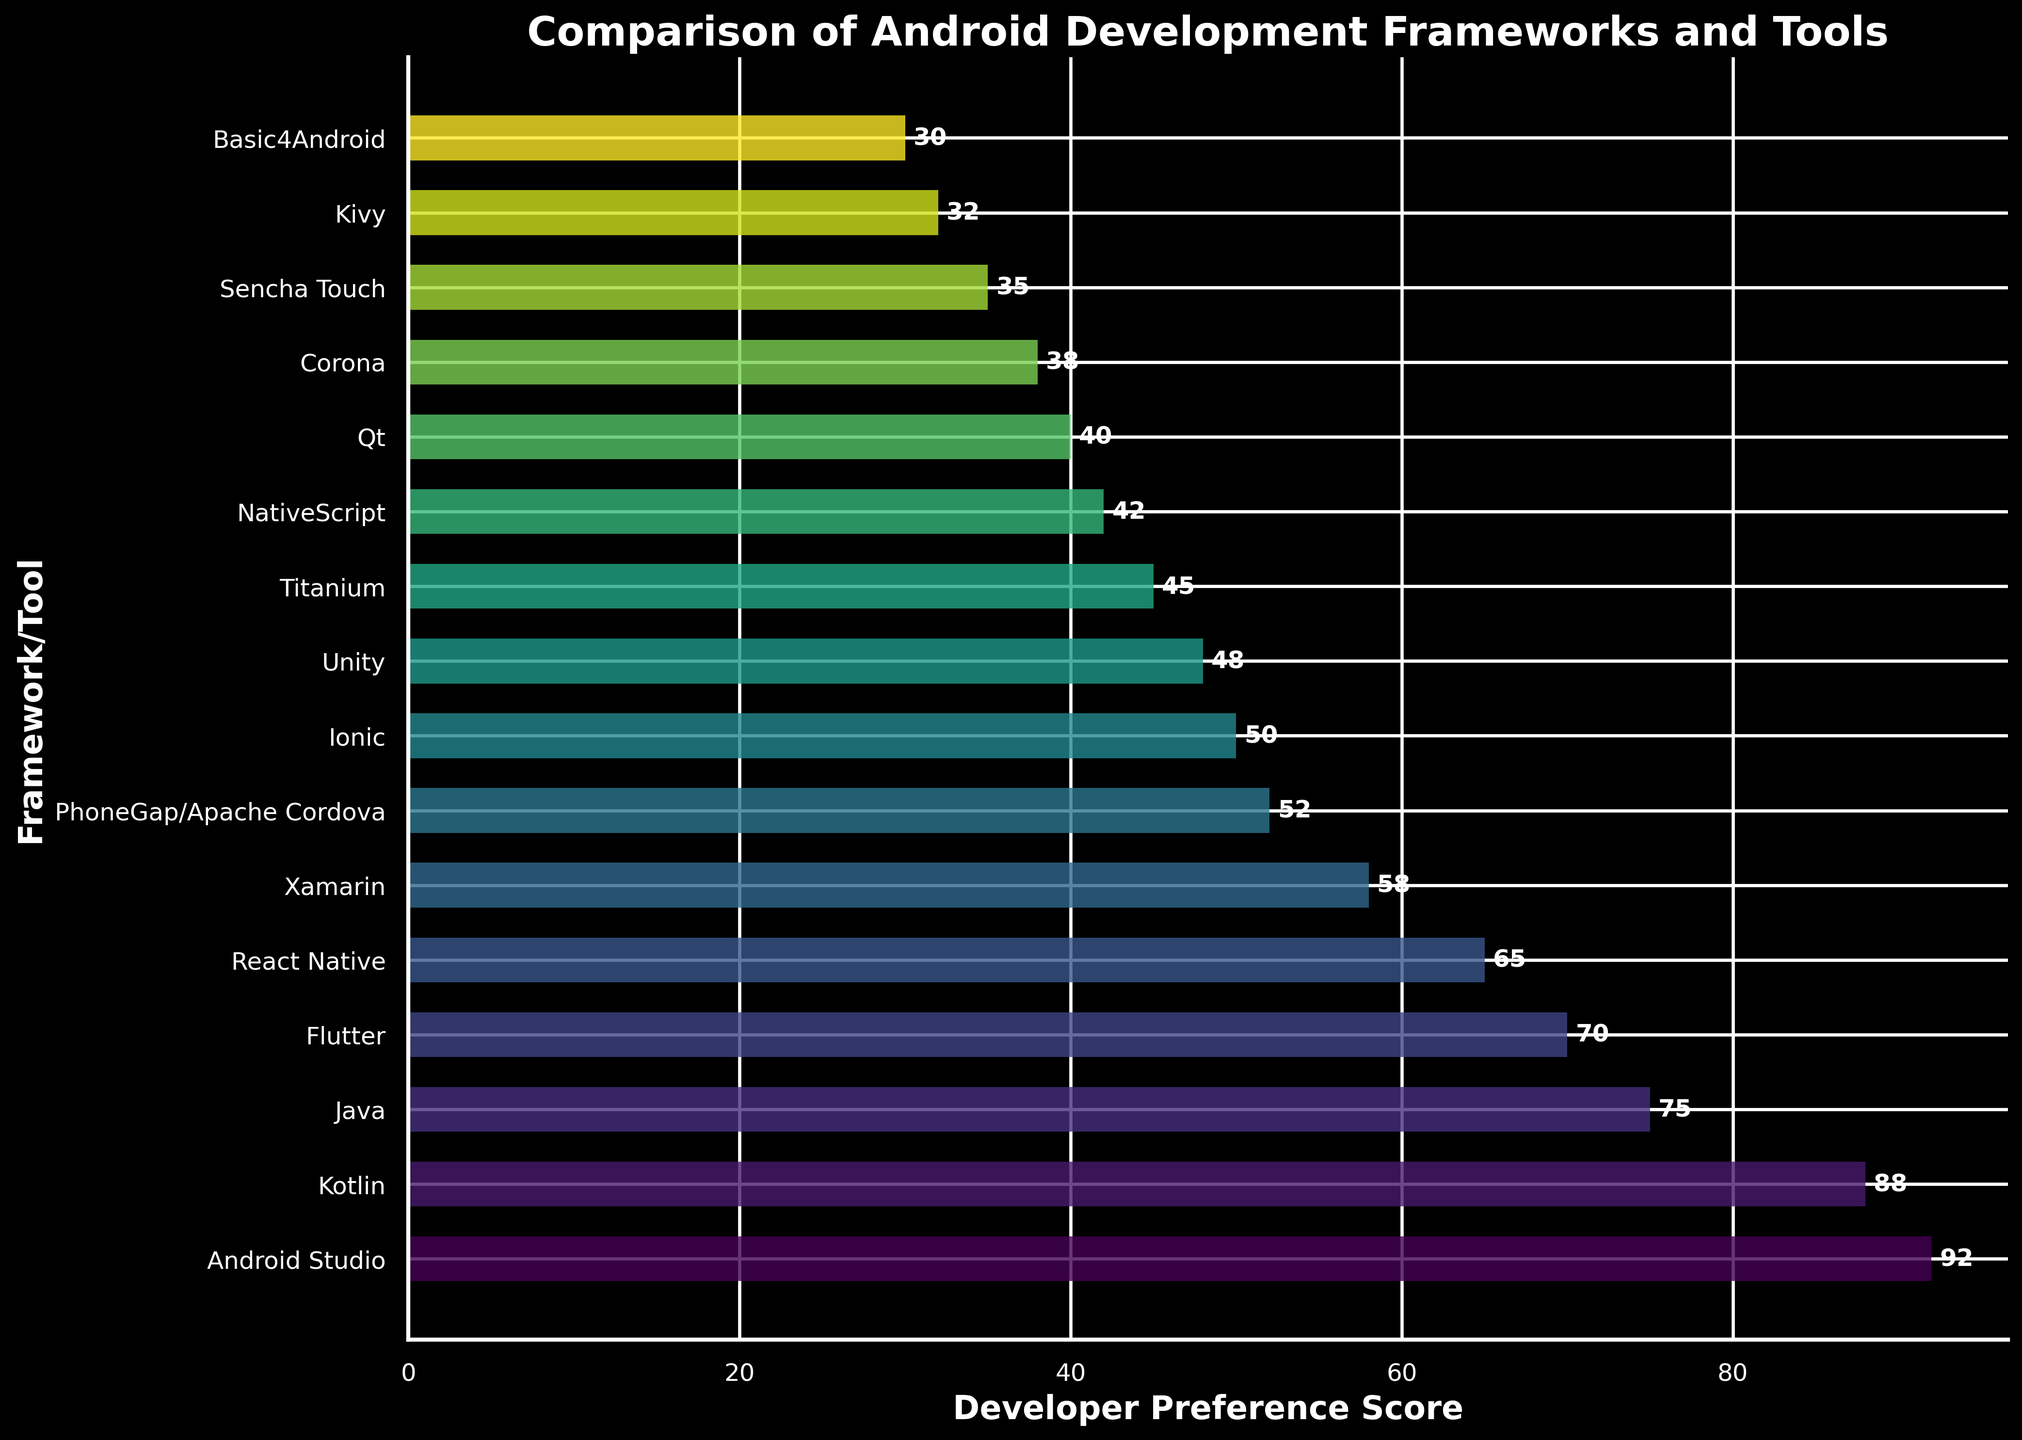Which framework/tool has the highest developer preference score? The figure indicates that Android Studio has the highest developer preference score as its bar extends the farthest to the right.
Answer: Android Studio What is the difference in preference scores between Android Studio and Xamarin? The developer preference score of Android Studio is 92, and for Xamarin, it is 58. The difference is calculated by subtracting 58 from 92.
Answer: 34 Which two frameworks/tools have the lowest preference scores? The figure shows that Basic4Android with a score of 30 and Kivy with a score of 32 have the lowest preference scores, as their bars are the shortest.
Answer: Basic4Android and Kivy How much higher is the preference score of Kotlin compared to Java? The preference score for Kotlin is 88 and for Java is 75. The difference is found by subtracting 75 from 88.
Answer: 13 What is the average preference score of Flutter, React Native, and Xamarin? The scores for Flutter, React Native, and Xamarin are 70, 65, and 58, respectively. Summing these scores gives 193. Dividing by 3, the average score is approximately 64.3.
Answer: 64.3 Which framework/tool falls exactly in the middle in terms of preference score ranking? There are 16 frameworks/tools listed, so the middle one position-wise would be the 8th one. In the ranking order, Ionic is the 8th framework/tool from the top.
Answer: Ionic Is the preference score of Unity greater than that of PhoneGap/Apache Cordova? The figure shows that Unity has a preference score of 48, while PhoneGap/Apache Cordova has a score of 52. 48 is less than 52.
Answer: No What is the combined score of the top three preferred frameworks/tools? The three frameworks/tools with the highest scores are Android Studio (92), Kotlin (88), and Java (75). Adding these up gives a combined score of 255.
Answer: 255 Which framework/tool's bar is visually closest in length to the bar of Qt? The framework/tool NativeScript, which has a score of 42, has a bar visually closest in length to that of Qt which has a score of 40.
Answer: NativeScript 